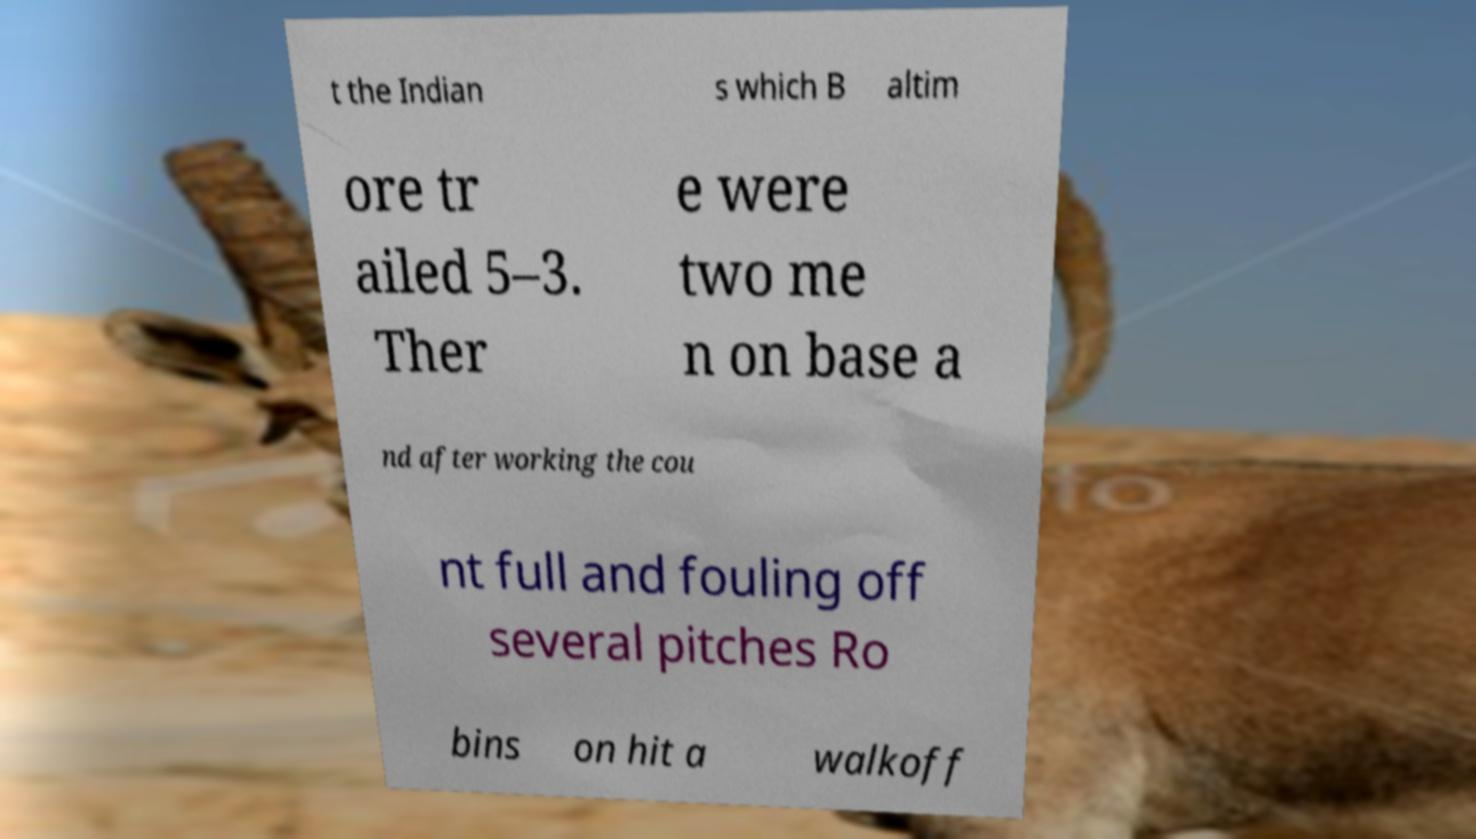Please identify and transcribe the text found in this image. t the Indian s which B altim ore tr ailed 5–3. Ther e were two me n on base a nd after working the cou nt full and fouling off several pitches Ro bins on hit a walkoff 